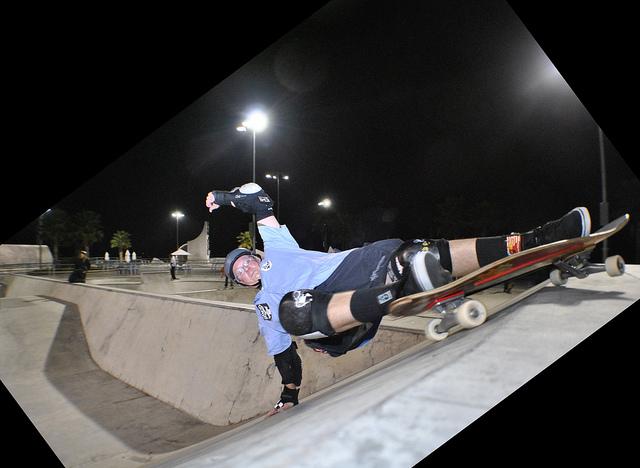What is the man doing?
Give a very brief answer. Skateboarding. Was this photo taken in the daytime?
Answer briefly. No. What is he doing?
Short answer required. Skateboarding. Which hand is holding the ramp?
Answer briefly. Right. 